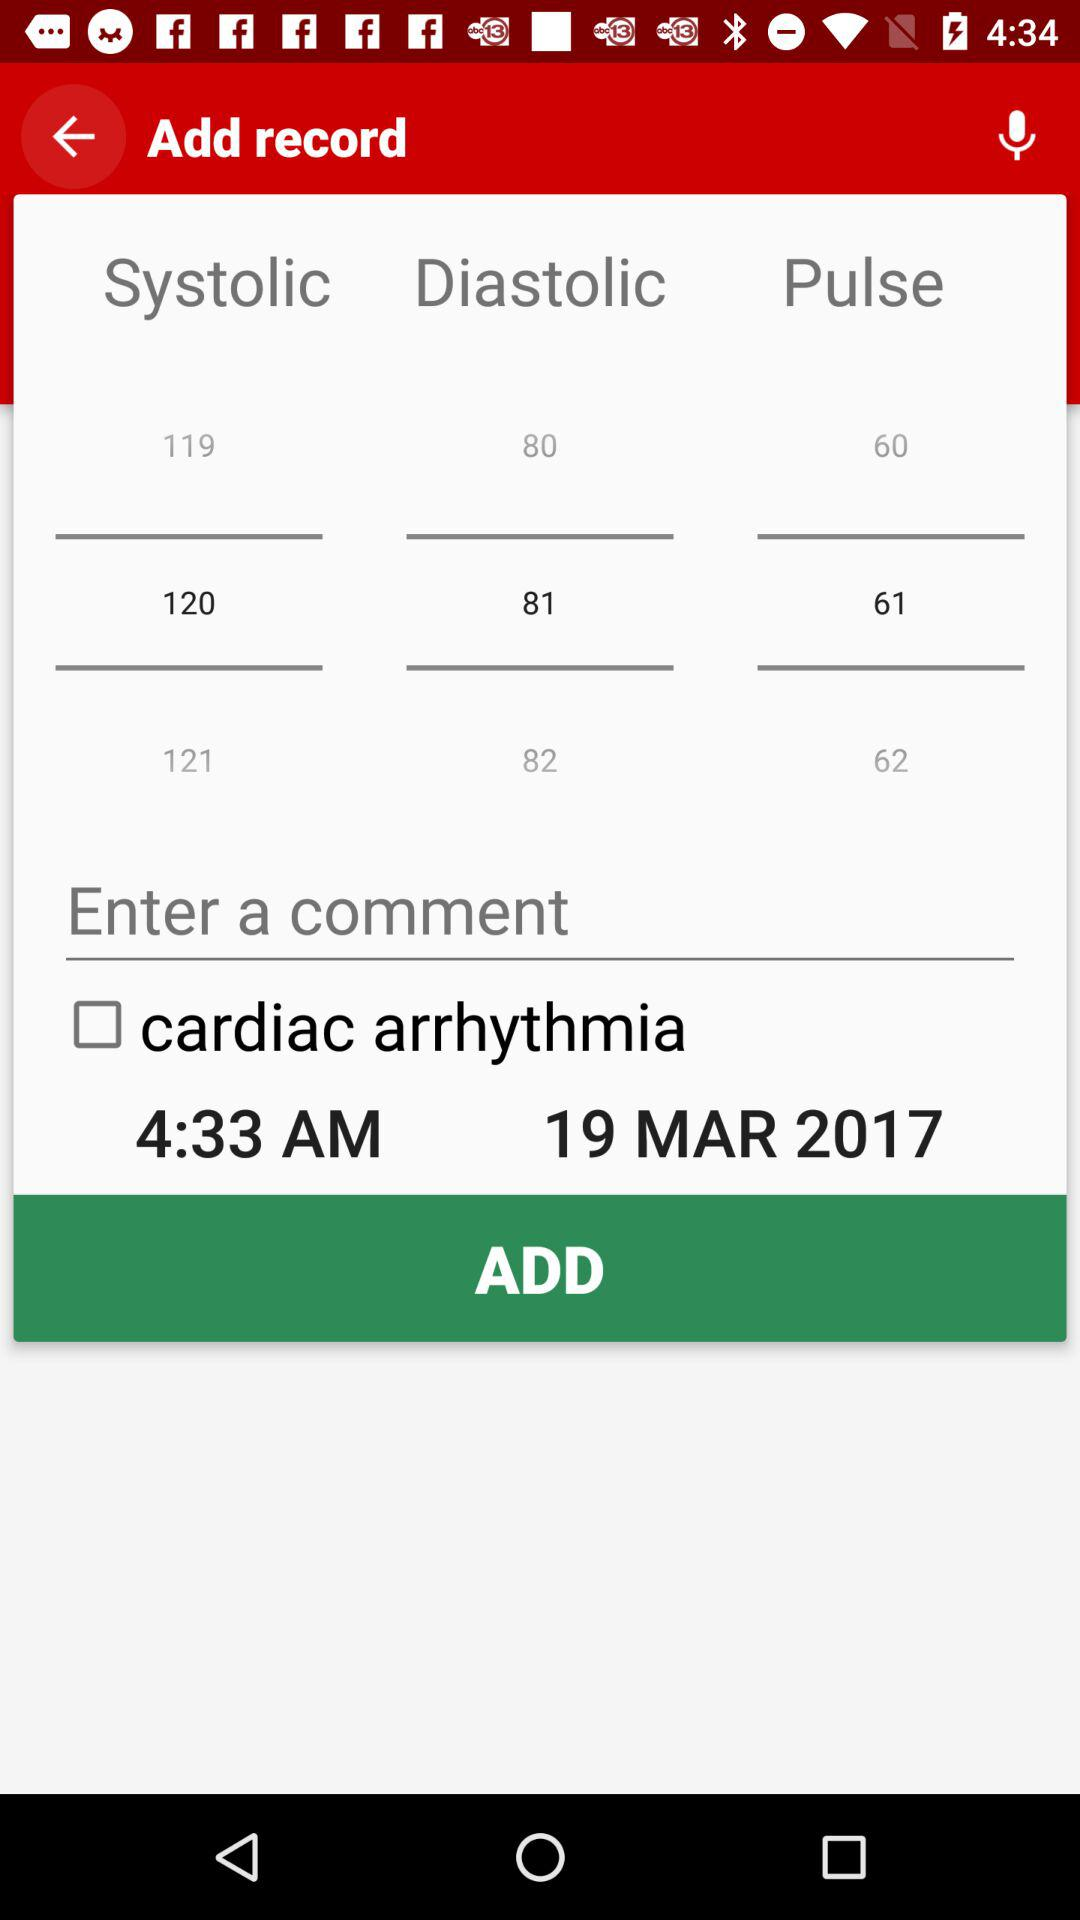What is the selected pulse rate? The selected pulse rate is 61. 